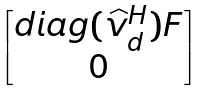<formula> <loc_0><loc_0><loc_500><loc_500>\begin{bmatrix} d i a g ( \widehat { v } _ { d } ^ { H } ) F \\ 0 \end{bmatrix}</formula> 